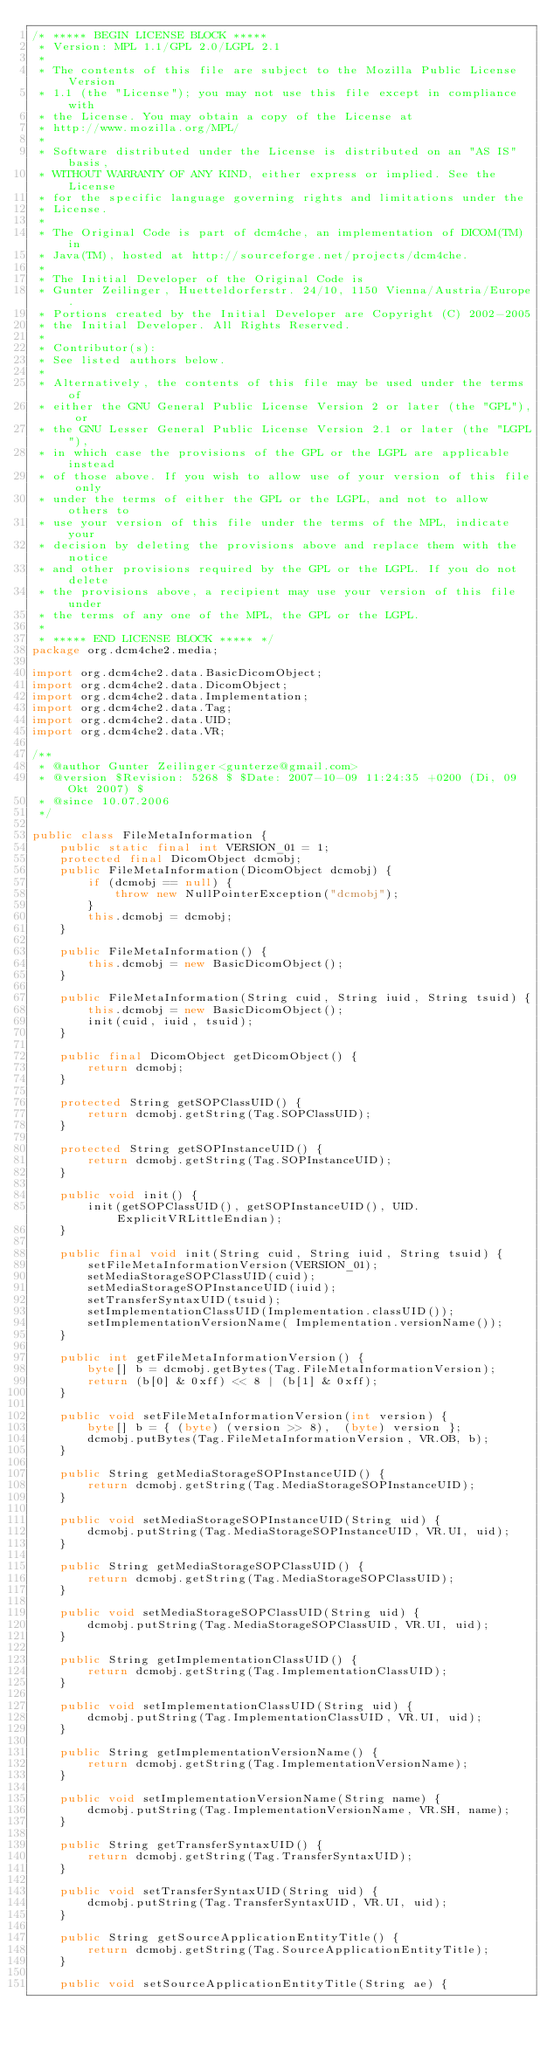<code> <loc_0><loc_0><loc_500><loc_500><_Java_>/* ***** BEGIN LICENSE BLOCK *****
 * Version: MPL 1.1/GPL 2.0/LGPL 2.1
 *
 * The contents of this file are subject to the Mozilla Public License Version
 * 1.1 (the "License"); you may not use this file except in compliance with
 * the License. You may obtain a copy of the License at
 * http://www.mozilla.org/MPL/
 *
 * Software distributed under the License is distributed on an "AS IS" basis,
 * WITHOUT WARRANTY OF ANY KIND, either express or implied. See the License
 * for the specific language governing rights and limitations under the
 * License.
 *
 * The Original Code is part of dcm4che, an implementation of DICOM(TM) in
 * Java(TM), hosted at http://sourceforge.net/projects/dcm4che.
 *
 * The Initial Developer of the Original Code is
 * Gunter Zeilinger, Huetteldorferstr. 24/10, 1150 Vienna/Austria/Europe.
 * Portions created by the Initial Developer are Copyright (C) 2002-2005
 * the Initial Developer. All Rights Reserved.
 *
 * Contributor(s):
 * See listed authors below.
 *
 * Alternatively, the contents of this file may be used under the terms of
 * either the GNU General Public License Version 2 or later (the "GPL"), or
 * the GNU Lesser General Public License Version 2.1 or later (the "LGPL"),
 * in which case the provisions of the GPL or the LGPL are applicable instead
 * of those above. If you wish to allow use of your version of this file only
 * under the terms of either the GPL or the LGPL, and not to allow others to
 * use your version of this file under the terms of the MPL, indicate your
 * decision by deleting the provisions above and replace them with the notice
 * and other provisions required by the GPL or the LGPL. If you do not delete
 * the provisions above, a recipient may use your version of this file under
 * the terms of any one of the MPL, the GPL or the LGPL.
 *
 * ***** END LICENSE BLOCK ***** */
package org.dcm4che2.media;

import org.dcm4che2.data.BasicDicomObject;
import org.dcm4che2.data.DicomObject;
import org.dcm4che2.data.Implementation;
import org.dcm4che2.data.Tag;
import org.dcm4che2.data.UID;
import org.dcm4che2.data.VR;

/**
 * @author Gunter Zeilinger<gunterze@gmail.com>
 * @version $Revision: 5268 $ $Date: 2007-10-09 11:24:35 +0200 (Di, 09 Okt 2007) $
 * @since 10.07.2006
 */

public class FileMetaInformation {
    public static final int VERSION_01 = 1;
    protected final DicomObject dcmobj;
    public FileMetaInformation(DicomObject dcmobj) {
        if (dcmobj == null) {
            throw new NullPointerException("dcmobj");
        }
        this.dcmobj = dcmobj;
    }

    public FileMetaInformation() {
        this.dcmobj = new BasicDicomObject();
    }
    
    public FileMetaInformation(String cuid, String iuid, String tsuid) {
        this.dcmobj = new BasicDicomObject();
        init(cuid, iuid, tsuid);
    }
    
    public final DicomObject getDicomObject() {
        return dcmobj;
    }

    protected String getSOPClassUID() {
        return dcmobj.getString(Tag.SOPClassUID);
    }

    protected String getSOPInstanceUID() {
        return dcmobj.getString(Tag.SOPInstanceUID);
    }

    public void init() {
        init(getSOPClassUID(), getSOPInstanceUID(), UID.ExplicitVRLittleEndian);
    }

    public final void init(String cuid, String iuid, String tsuid) {
        setFileMetaInformationVersion(VERSION_01);
        setMediaStorageSOPClassUID(cuid);
        setMediaStorageSOPInstanceUID(iuid);
        setTransferSyntaxUID(tsuid);
        setImplementationClassUID(Implementation.classUID());
        setImplementationVersionName( Implementation.versionName());
    }

    public int getFileMetaInformationVersion() {
        byte[] b = dcmobj.getBytes(Tag.FileMetaInformationVersion);
        return (b[0] & 0xff) << 8 | (b[1] & 0xff);
    }

    public void setFileMetaInformationVersion(int version) {
        byte[] b = { (byte) (version >> 8),  (byte) version };
        dcmobj.putBytes(Tag.FileMetaInformationVersion, VR.OB, b);
    }

    public String getMediaStorageSOPInstanceUID() {
        return dcmobj.getString(Tag.MediaStorageSOPInstanceUID);
    }

    public void setMediaStorageSOPInstanceUID(String uid) {
        dcmobj.putString(Tag.MediaStorageSOPInstanceUID, VR.UI, uid);
    }

    public String getMediaStorageSOPClassUID() {
        return dcmobj.getString(Tag.MediaStorageSOPClassUID);
    }

    public void setMediaStorageSOPClassUID(String uid) {
        dcmobj.putString(Tag.MediaStorageSOPClassUID, VR.UI, uid);
    }

    public String getImplementationClassUID() {
        return dcmobj.getString(Tag.ImplementationClassUID);
    }

    public void setImplementationClassUID(String uid) {
        dcmobj.putString(Tag.ImplementationClassUID, VR.UI, uid);
    }
    
    public String getImplementationVersionName() {
        return dcmobj.getString(Tag.ImplementationVersionName);
    }

    public void setImplementationVersionName(String name) {
        dcmobj.putString(Tag.ImplementationVersionName, VR.SH, name);
    }

    public String getTransferSyntaxUID() {
        return dcmobj.getString(Tag.TransferSyntaxUID);
    }

    public void setTransferSyntaxUID(String uid) {
        dcmobj.putString(Tag.TransferSyntaxUID, VR.UI, uid);
    }
    
    public String getSourceApplicationEntityTitle() {
        return dcmobj.getString(Tag.SourceApplicationEntityTitle);
    }

    public void setSourceApplicationEntityTitle(String ae) {</code> 